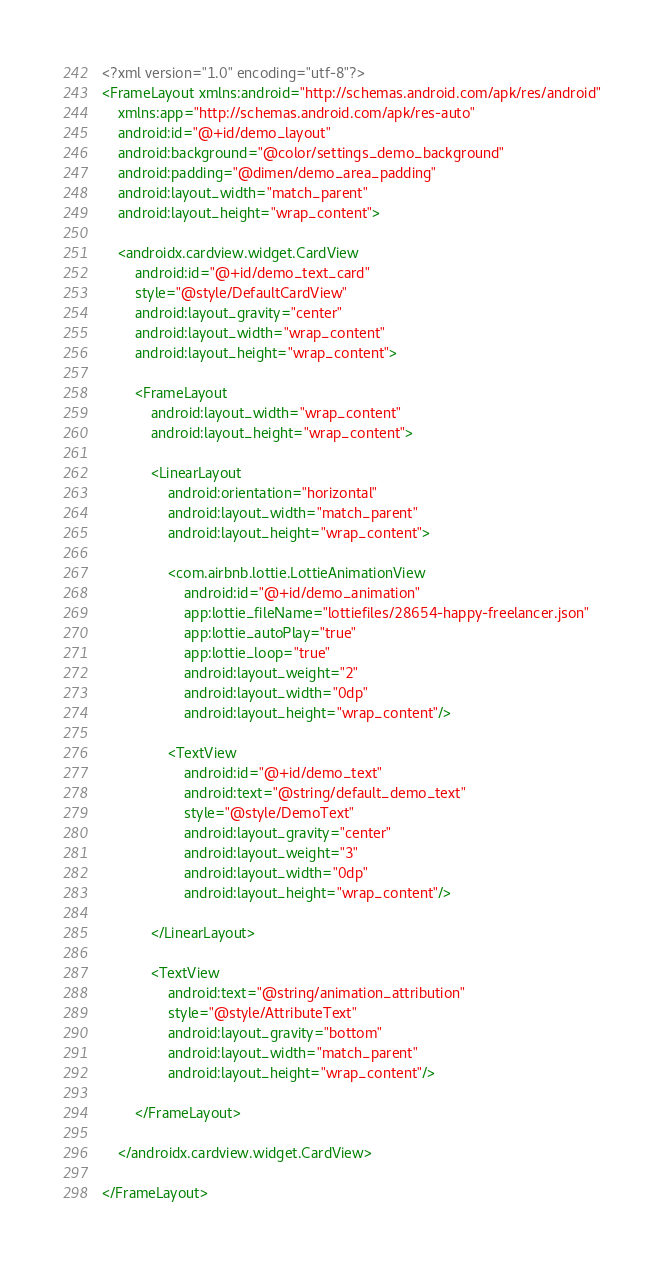<code> <loc_0><loc_0><loc_500><loc_500><_XML_><?xml version="1.0" encoding="utf-8"?>
<FrameLayout xmlns:android="http://schemas.android.com/apk/res/android"
    xmlns:app="http://schemas.android.com/apk/res-auto"
    android:id="@+id/demo_layout"
    android:background="@color/settings_demo_background"
    android:padding="@dimen/demo_area_padding"
    android:layout_width="match_parent"
    android:layout_height="wrap_content">

    <androidx.cardview.widget.CardView
        android:id="@+id/demo_text_card"
        style="@style/DefaultCardView"
        android:layout_gravity="center"
        android:layout_width="wrap_content"
        android:layout_height="wrap_content">

        <FrameLayout
            android:layout_width="wrap_content"
            android:layout_height="wrap_content">

            <LinearLayout
                android:orientation="horizontal"
                android:layout_width="match_parent"
                android:layout_height="wrap_content">

                <com.airbnb.lottie.LottieAnimationView
                    android:id="@+id/demo_animation"
                    app:lottie_fileName="lottiefiles/28654-happy-freelancer.json"
                    app:lottie_autoPlay="true"
                    app:lottie_loop="true"
                    android:layout_weight="2"
                    android:layout_width="0dp"
                    android:layout_height="wrap_content"/>

                <TextView
                    android:id="@+id/demo_text"
                    android:text="@string/default_demo_text"
                    style="@style/DemoText"
                    android:layout_gravity="center"
                    android:layout_weight="3"
                    android:layout_width="0dp"
                    android:layout_height="wrap_content"/>

            </LinearLayout>

            <TextView
                android:text="@string/animation_attribution"
                style="@style/AttributeText"
                android:layout_gravity="bottom"
                android:layout_width="match_parent"
                android:layout_height="wrap_content"/>

        </FrameLayout>

    </androidx.cardview.widget.CardView>

</FrameLayout>
</code> 